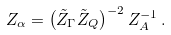Convert formula to latex. <formula><loc_0><loc_0><loc_500><loc_500>Z _ { \alpha } = \left ( \tilde { Z } _ { \Gamma } \tilde { Z } _ { Q } \right ) ^ { - 2 } Z _ { A } ^ { - 1 } \, .</formula> 